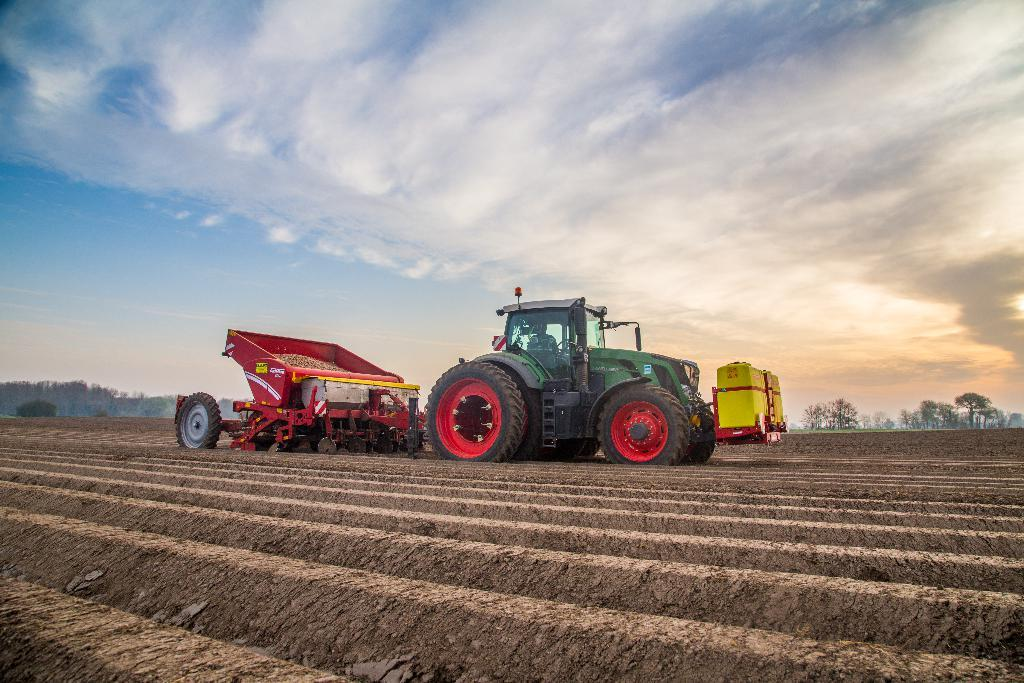What type of vehicles are in the image? There is a tractor and a truck in the image. Where are the tractor and truck located? They are on a field in the image. What can be seen in the background of the image? There are trees and the sky visible in the background. What type of door can be seen on the tractor in the image? There is no door present on the tractor in the image. What type of rake is being used by the tractor in the image? There is no rake present in the image; the tractor is not performing any tasks in the image. 